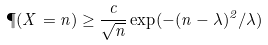<formula> <loc_0><loc_0><loc_500><loc_500>\P ( X = n ) \geq \frac { c } { \sqrt { n } } \exp ( - ( n - \lambda ) ^ { 2 } / \lambda )</formula> 